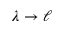<formula> <loc_0><loc_0><loc_500><loc_500>\lambda \to \ell</formula> 